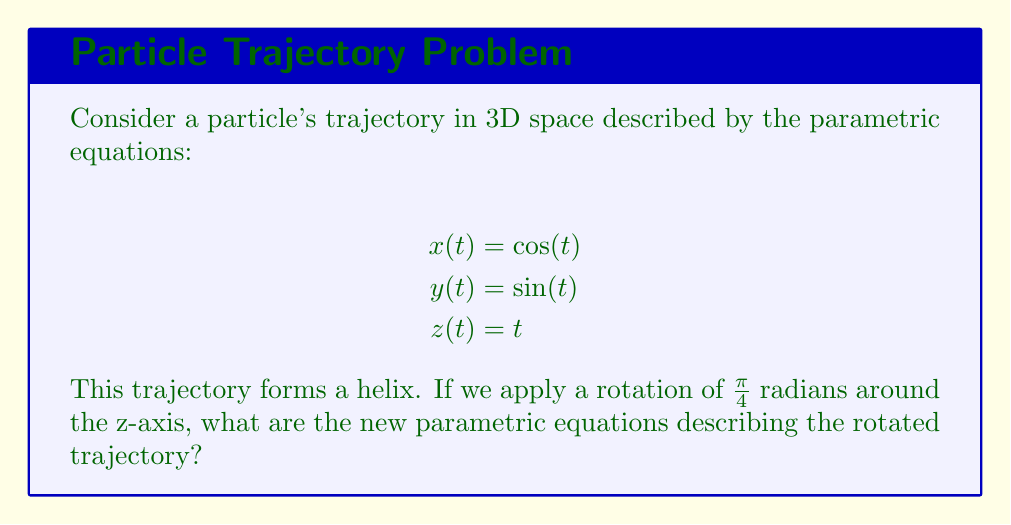What is the answer to this math problem? To solve this problem, we need to apply the rotation matrix for a rotation around the z-axis. The rotation matrix for a counterclockwise rotation of angle $\theta$ around the z-axis is:

$$R_z(\theta) = \begin{pmatrix}
\cos(\theta) & -\sin(\theta) & 0 \\
\sin(\theta) & \cos(\theta) & 0 \\
0 & 0 & 1
\end{pmatrix}$$

In this case, $\theta = \frac{\pi}{4}$. Let's apply this rotation to our original parametric equations:

1) First, we create a vector of our original functions:
   $$\vec{r}(t) = \begin{pmatrix} x(t) \\ y(t) \\ z(t) \end{pmatrix} = \begin{pmatrix} \cos(t) \\ \sin(t) \\ t \end{pmatrix}$$

2) Now, we multiply our rotation matrix by this vector:
   $$\vec{r}'(t) = R_z(\frac{\pi}{4}) \cdot \vec{r}(t)$$

   $$\begin{pmatrix}
   \cos(\frac{\pi}{4}) & -\sin(\frac{\pi}{4}) & 0 \\
   \sin(\frac{\pi}{4}) & \cos(\frac{\pi}{4}) & 0 \\
   0 & 0 & 1
   \end{pmatrix} \cdot \begin{pmatrix} \cos(t) \\ \sin(t) \\ t \end{pmatrix}$$

3) Perform the matrix multiplication:
   $$\begin{pmatrix}
   \cos(\frac{\pi}{4})\cos(t) - \sin(\frac{\pi}{4})\sin(t) \\
   \sin(\frac{\pi}{4})\cos(t) + \cos(\frac{\pi}{4})\sin(t) \\
   t
   \end{pmatrix}$$

4) Simplify using the values of $\cos(\frac{\pi}{4})$ and $\sin(\frac{\pi}{4})$, which are both equal to $\frac{\sqrt{2}}{2}$:
   $$\begin{pmatrix}
   \frac{\sqrt{2}}{2}\cos(t) - \frac{\sqrt{2}}{2}\sin(t) \\
   \frac{\sqrt{2}}{2}\cos(t) + \frac{\sqrt{2}}{2}\sin(t) \\
   t
   \end{pmatrix}$$

5) These components give us our new parametric equations:
   $$x'(t) = \frac{\sqrt{2}}{2}(\cos(t) - \sin(t))$$
   $$y'(t) = \frac{\sqrt{2}}{2}(\cos(t) + \sin(t))$$
   $$z'(t) = t$$
Answer: The new parametric equations after rotation are:

$$x'(t) = \frac{\sqrt{2}}{2}(\cos(t) - \sin(t))$$
$$y'(t) = \frac{\sqrt{2}}{2}(\cos(t) + \sin(t))$$
$$z'(t) = t$$ 